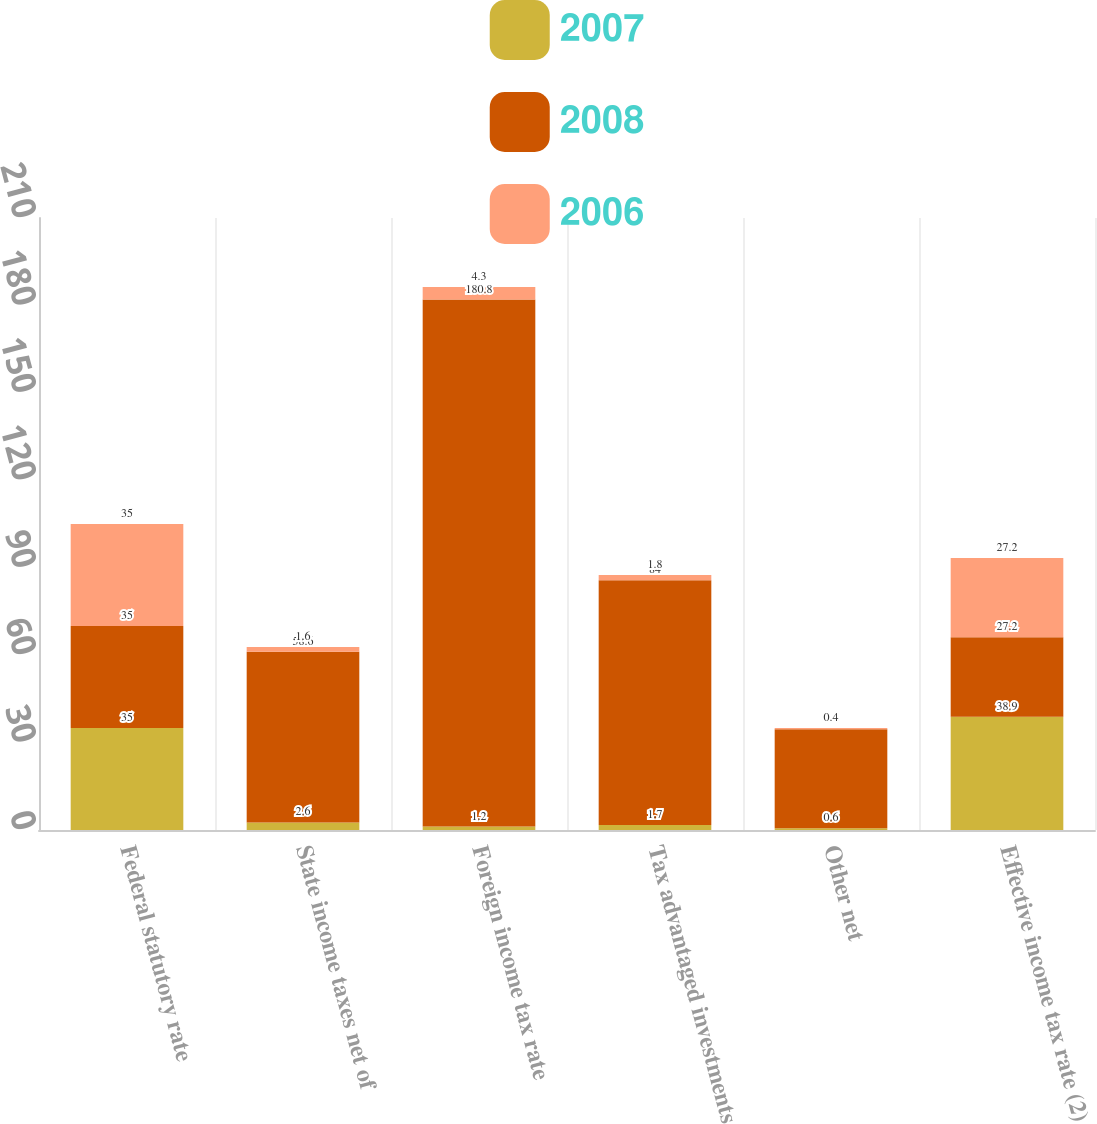Convert chart. <chart><loc_0><loc_0><loc_500><loc_500><stacked_bar_chart><ecel><fcel>Federal statutory rate<fcel>State income taxes net of<fcel>Foreign income tax rate<fcel>Tax advantaged investments<fcel>Other net<fcel>Effective income tax rate (2)<nl><fcel>2007<fcel>35<fcel>2.6<fcel>1.2<fcel>1.7<fcel>0.6<fcel>38.9<nl><fcel>2008<fcel>35<fcel>58.6<fcel>180.8<fcel>84<fcel>34<fcel>27.2<nl><fcel>2006<fcel>35<fcel>1.6<fcel>4.3<fcel>1.8<fcel>0.4<fcel>27.2<nl></chart> 